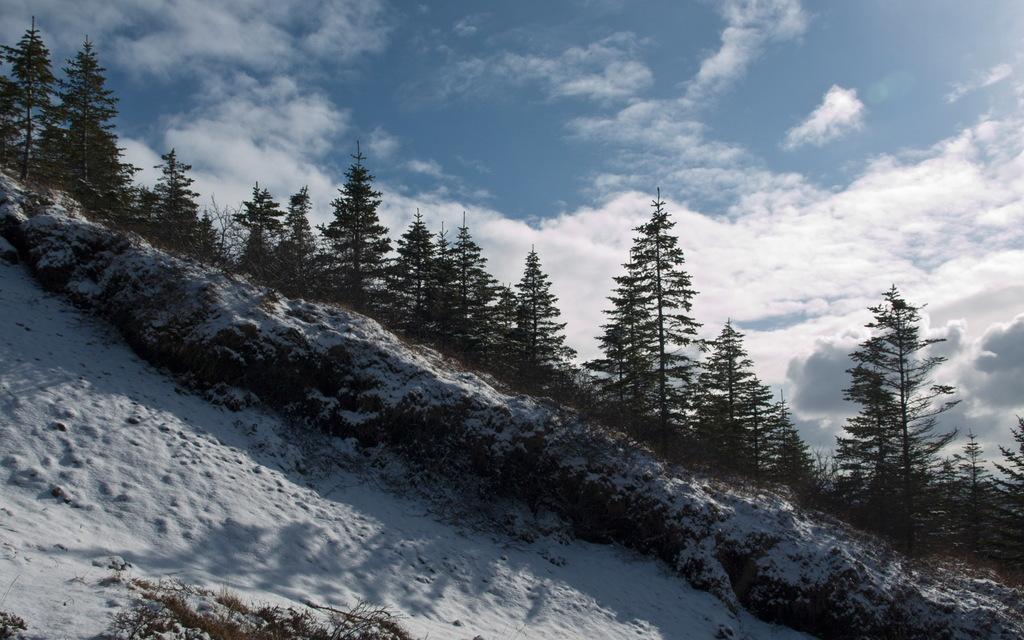Describe this image in one or two sentences. In this picture we can see snow at the bottom, in the background there are some trees, we can see the sky and clouds at the top of the picture. 